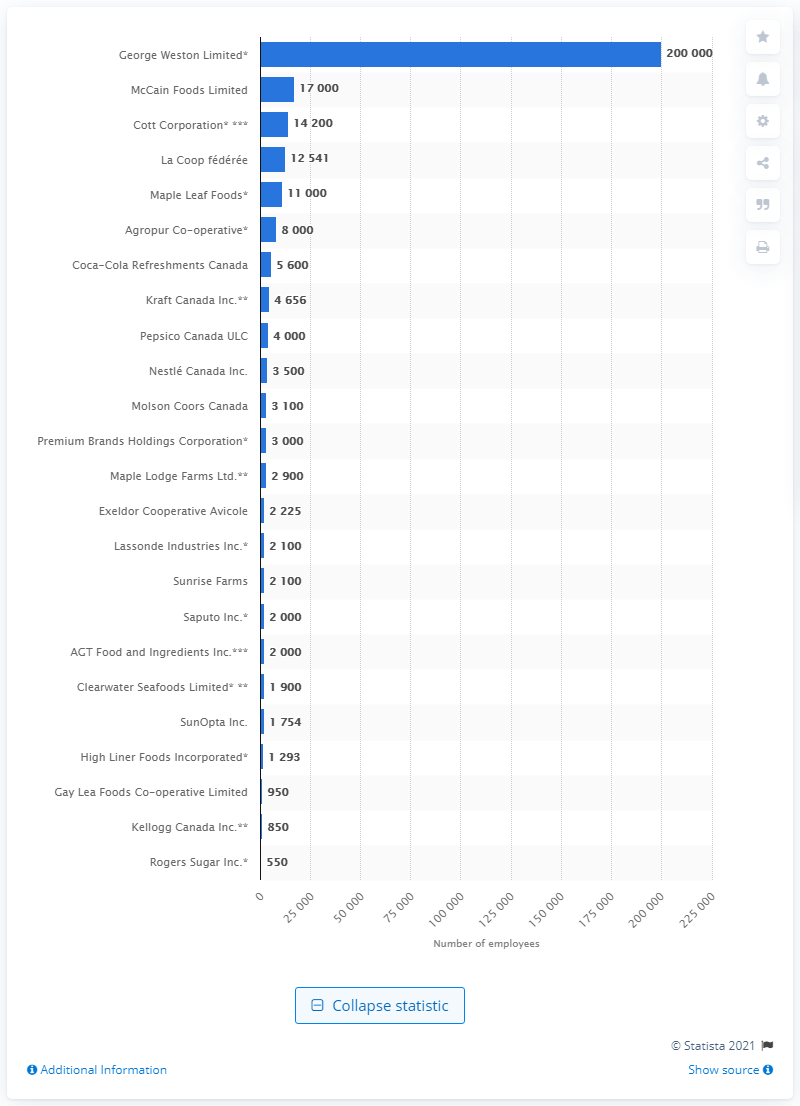Identify some key points in this picture. McCain Foods Limited is the second largest food and beverage company in terms of employee numbers. In 2016, McCain Foods Limited employed approximately 17,000 people in Canada. 